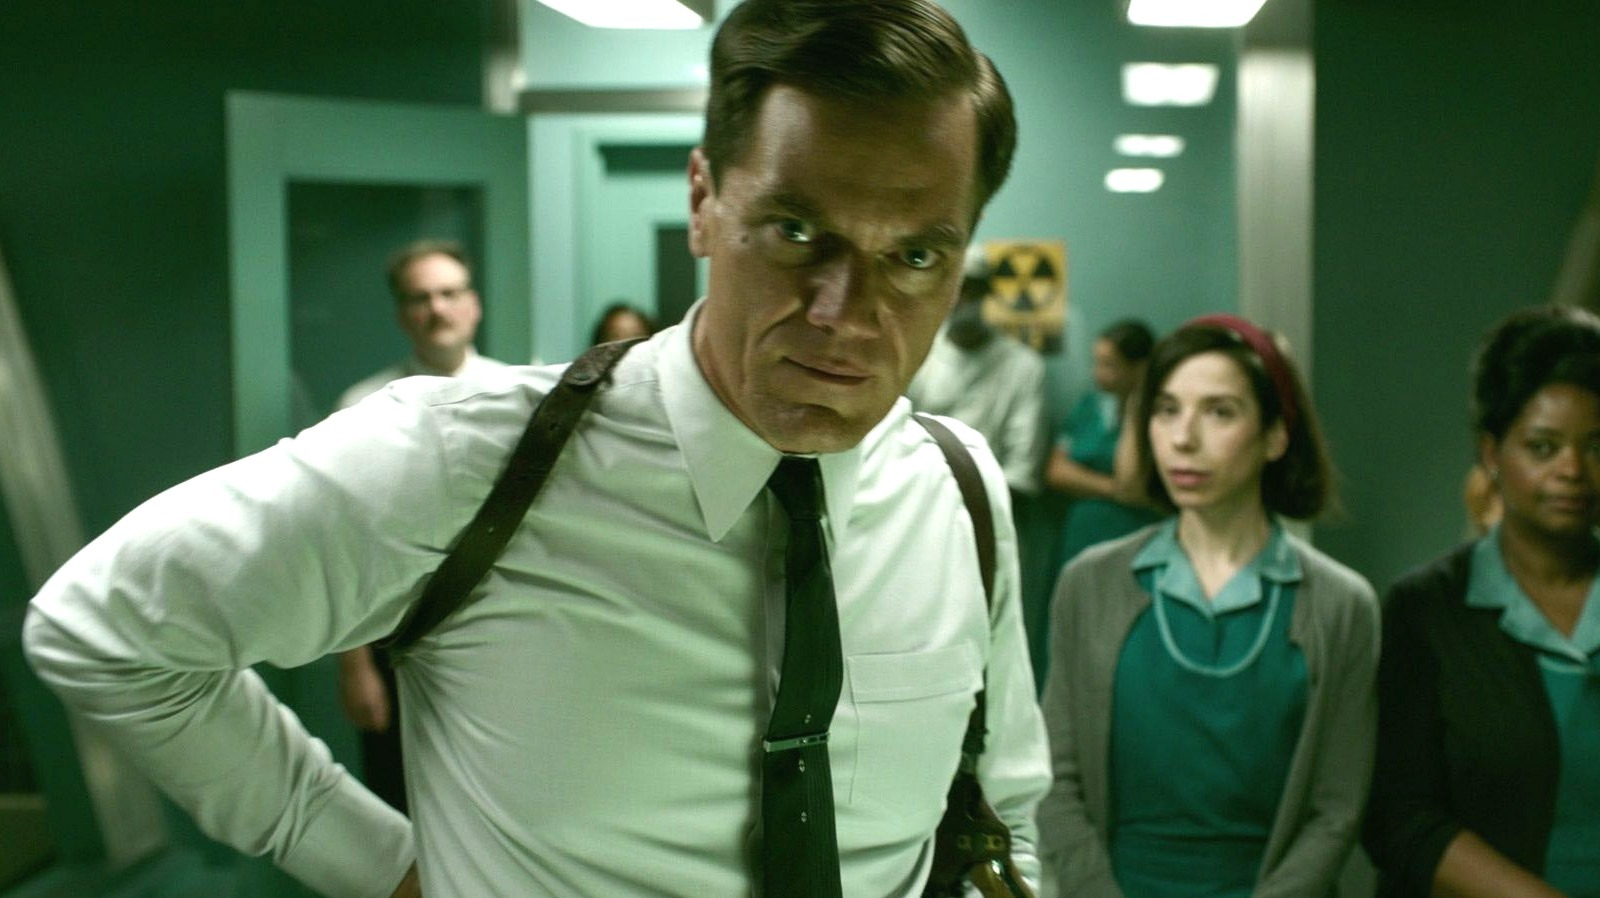Can you describe the role of the woman in teal in the background? The woman in the teal dress seems to play a supportive role in the scene, potentially a nurse or medical assistant. Her attire and partial attention towards the main figure suggest she is involved in the unfolding events, possibly awaiting instructions or observing the situation unfold. 